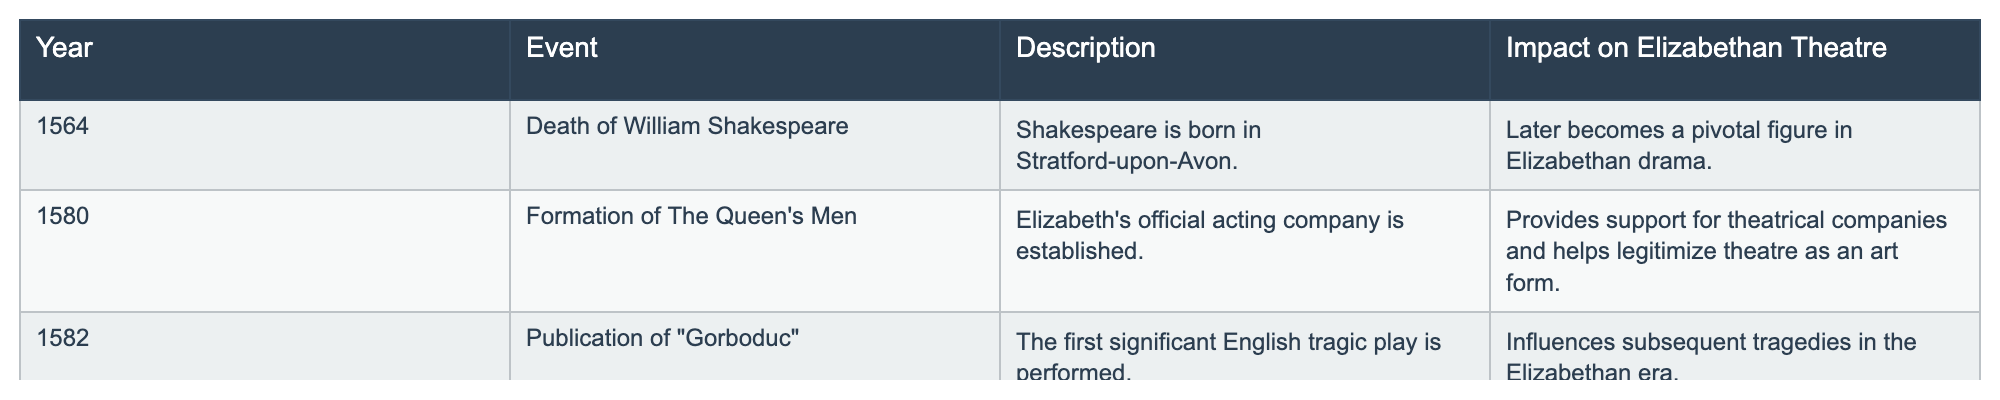What year did the formation of The Queen's Men occur? The table lists the event of The Queen's Men formation under the "Year" column, which shows it occurred in 1580.
Answer: 1580 What significant English tragic play was performed in 1582? Referring to the table, it states that "Gorboduc" was the first significant English tragic play performed in 1582.
Answer: Gorboduc Was the birth of William Shakespeare a pivotal event for Elizabethan drama? According to the table, Shakespeare's birth in 1564 is noted as a pivotal figure in the development of Elizabethan drama, implying it was indeed significant.
Answer: Yes What impact did the publication of "Gorboduc" have on Elizabethan theatre? The table indicates that the performance of "Gorboduc" influenced subsequent tragedies, showcasing its importance in shaping the theatrical landscape.
Answer: Influenced subsequent tragedies How many events in the table indicate a positive impact on Elizabethan theatre? There are three events listed in the table, and all of them are described with positive impacts on Elizabethan theatre development. Therefore, the total is 3.
Answer: 3 Did the establishment of The Queen's Men provide support for theatrical companies? The description in the table confirms that the formation of The Queen's Men did indeed provide support for theatrical companies, thereby affirming its positive impact.
Answer: Yes Compare the significance of The Queen's Men to other events listed. The establishment of The Queen's Men is the first organized official acting company, which helped legitimize theatre, while other events like Shakespeare's birth and "Gorboduc" are pivotal yet do not establish companies. This shows that the Queen's Men had a unique societal impact compared to the other events.
Answer: The Queen's Men was uniquely significant in legitimizing theatre What other events besides the formation of The Queen's Men contributed to legitimizing theatre? The table indicates that the establishment of The Queen's Men was focused on legitimizing theatre, while "Gorboduc" was more about influencing the type of plays performed. Hence, only that event contributed directly to theater’s legitimacy.
Answer: Only The Queen's Men What was the main event in 1564 according to the table? The table specifies that the main event for 1564 was the birth of William Shakespeare.
Answer: Birth of Shakespeare 